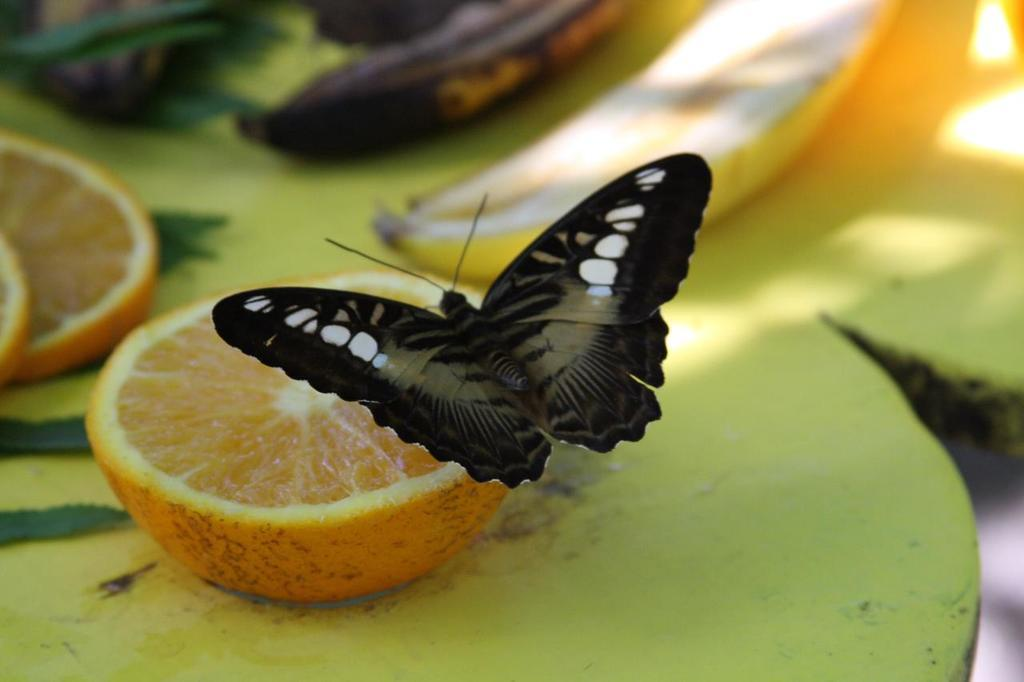What type of insect can be seen in the image? There is a butterfly in the image. What type of fruit is present in the image? There are orange slices and other fruits in the image. Where are the fruits and orange slices located? The fruits and orange slices are on a platform in the image. What type of beast is lurking behind the butterfly in the image? There is no beast present in the image; it only features a butterfly and fruits. 